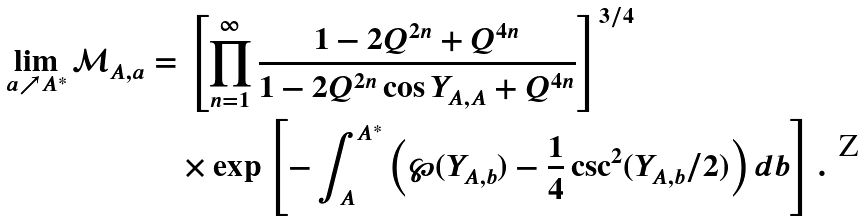Convert formula to latex. <formula><loc_0><loc_0><loc_500><loc_500>\lim _ { a \nearrow A ^ { * } } \mathcal { M } _ { A , a } & = \left [ \prod _ { n = 1 } ^ { \infty } \frac { 1 - 2 Q ^ { 2 n } + Q ^ { 4 n } } { 1 - 2 Q ^ { 2 n } \cos Y _ { A , A } + Q ^ { 4 n } } \right ] ^ { 3 / 4 } \\ & \quad \times \exp \left [ - \int _ { A } ^ { A ^ { * } } \left ( \wp ( Y _ { A , b } ) - \frac { 1 } { 4 } \csc ^ { 2 } ( Y _ { A , b } / 2 ) \right ) d b \right ] .</formula> 